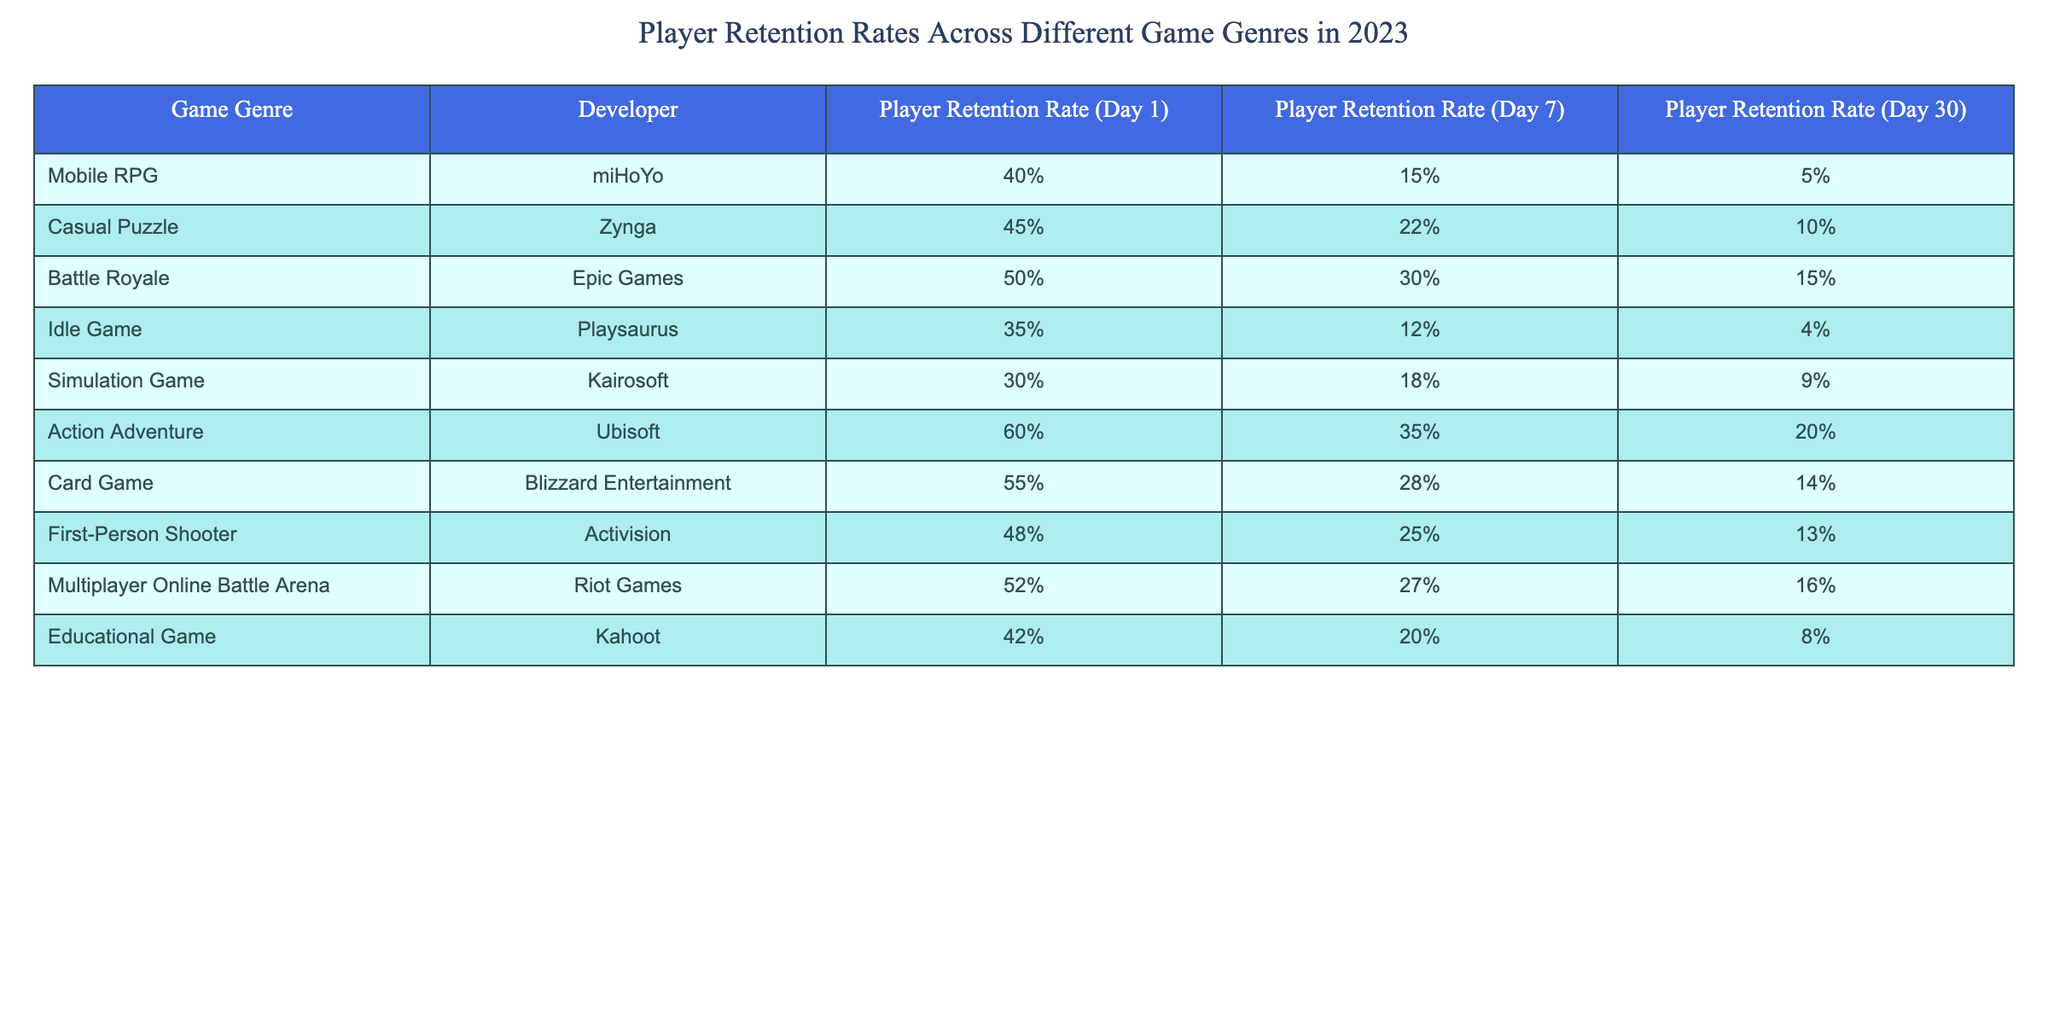What is the Player Retention Rate for Action Adventure games on Day 1? The table indicates that the Player Retention Rate for Action Adventure games (developed by Ubisoft) on Day 1 is 60%. Therefore, the answer is straightforward and can be found directly in the "Player Retention Rate (Day 1)" column for this genre.
Answer: 60% What is the lowest Player Retention Rate on Day 30 among the genres listed? By reviewing the Player Retention Rate (Day 30) column, the Idle Game has the lowest retention rate at 4%. We compare this value with all other genres to confirm this is the minimum value.
Answer: 4% Which game genre has the highest Player Retention Rate on Day 7? Looking at the Player Retention Rate (Day 7) column, Action Adventure games have the highest rate at 35%. This is the highest value when comparing all genres listed under that column.
Answer: 35% Is the Player Retention Rate for Battle Royale games on Day 1 greater than 45%? By checking the Player Retention Rate (Day 1) for Battle Royale, which is 50%, we confirm that it is indeed greater than 45%. Thus, the statement is true.
Answer: Yes What is the average Player Retention Rate on Day 30 across all game genres? To find the average, we sum the Player Retention Rates for Day 30: 5 + 10 + 15 + 4 + 9 + 20 + 14 + 13 + 16 + 8 =  110. There are 10 genres, so we divide the sum by 10. 110/10 = 11. Therefore, the average retention rate on Day 30 is 11%.
Answer: 11% What is the difference in Player Retention Rate on Day 1 between Mobile RPG and Card Game genres? The Player Retention Rate for Mobile RPG is 40%, and for Card Game, it is 55%. To find the difference, we subtract 40% from 55%, which results in 15%. Therefore, the difference on Day 1 is 15%.
Answer: 15% Are Casual Puzzle games more successful in retaining players on Day 7 compared to Educational Games? The Player Retention Rate for Casual Puzzle games on Day 7 is 22%, while for Educational Games, it is 20%. Since 22% is higher than 20%, Casual Puzzle genres do indeed retain more players. Thus, the answer is true.
Answer: Yes Which genre has a lower Player Retention Rate on Day 30: Simulation Games or Idle Games? Simulation Games have a retention rate of 9% on Day 30, while Idle Games have a lower rate of 4%. Therefore, Idle Games have a lower retention rate on Day 30 than Simulation Games, confirming our hypothesis.
Answer: Idle Games 